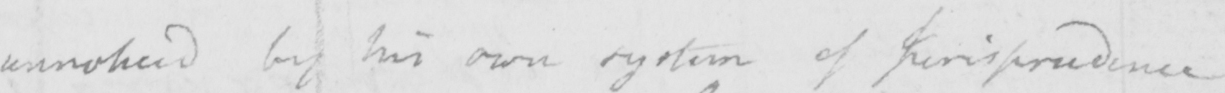Can you read and transcribe this handwriting? unnoticed by his own system of Jurisprudence 